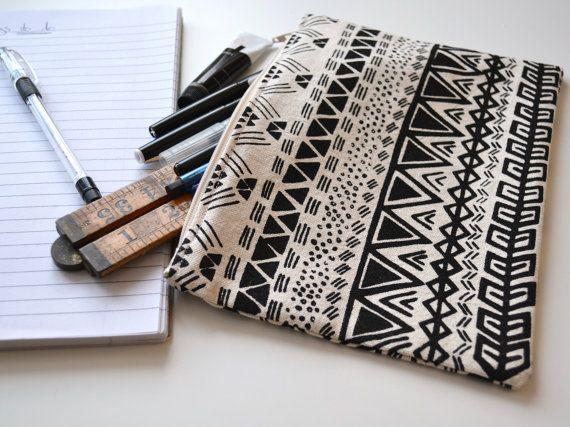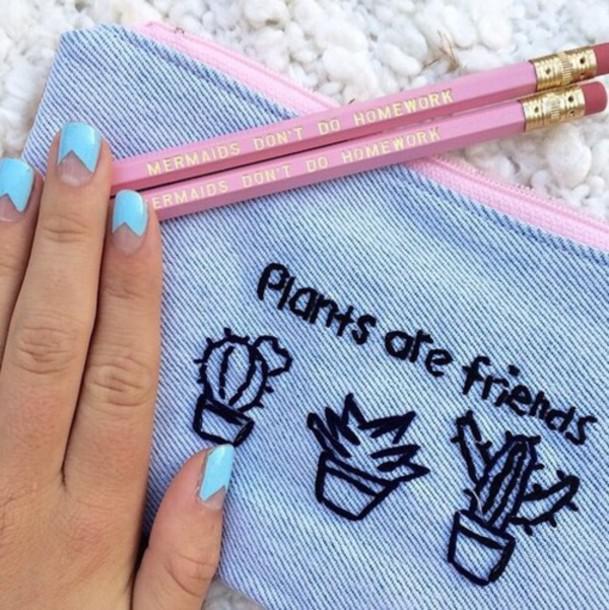The first image is the image on the left, the second image is the image on the right. Evaluate the accuracy of this statement regarding the images: "One image shows a black-and-white pencil case made of patterned fabric, and the other shows a case with a phrase across the front.". Is it true? Answer yes or no. Yes. The first image is the image on the left, the second image is the image on the right. Analyze the images presented: Is the assertion "There are exactly two pencil bags, and there are pencils and/or pens sticking out of the left one." valid? Answer yes or no. Yes. 